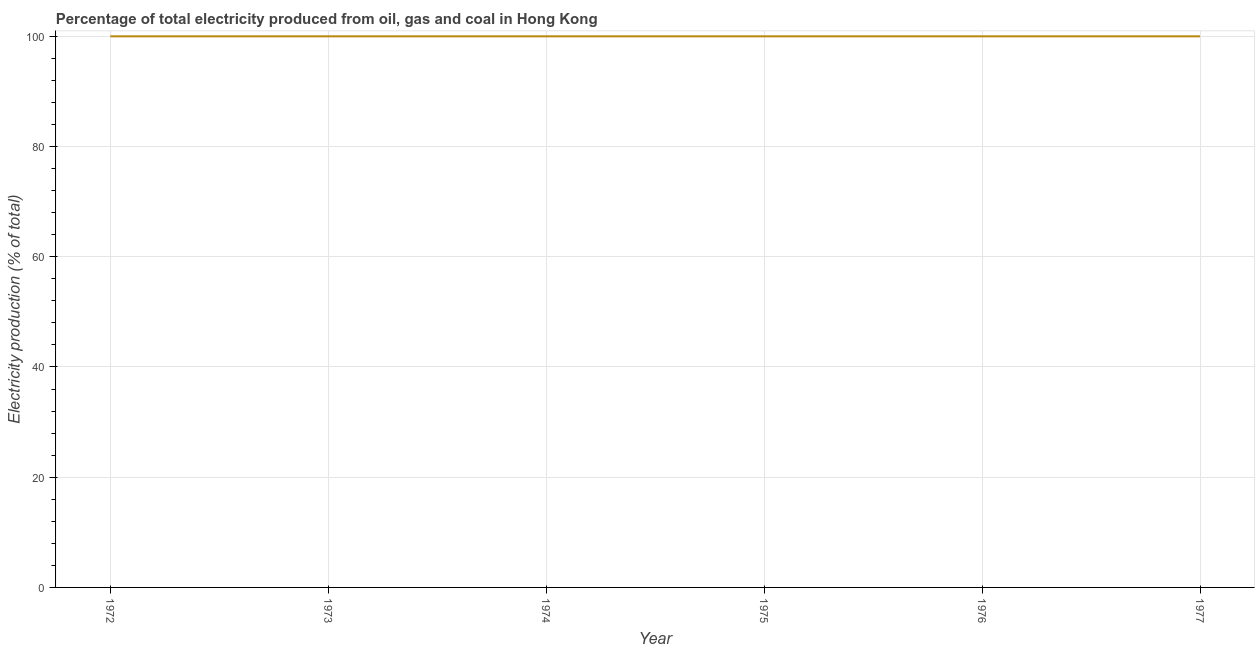What is the electricity production in 1975?
Your answer should be very brief. 100. Across all years, what is the maximum electricity production?
Give a very brief answer. 100. Across all years, what is the minimum electricity production?
Your response must be concise. 100. What is the sum of the electricity production?
Provide a short and direct response. 600. What is the median electricity production?
Keep it short and to the point. 100. Do a majority of the years between 1977 and 1972 (inclusive) have electricity production greater than 24 %?
Ensure brevity in your answer.  Yes. What is the ratio of the electricity production in 1973 to that in 1974?
Give a very brief answer. 1. Is the electricity production in 1975 less than that in 1976?
Your answer should be very brief. No. Is the difference between the electricity production in 1972 and 1976 greater than the difference between any two years?
Give a very brief answer. Yes. What is the difference between the highest and the second highest electricity production?
Provide a short and direct response. 0. What is the difference between the highest and the lowest electricity production?
Provide a short and direct response. 0. How many lines are there?
Your answer should be very brief. 1. What is the difference between two consecutive major ticks on the Y-axis?
Your response must be concise. 20. Does the graph contain any zero values?
Keep it short and to the point. No. What is the title of the graph?
Ensure brevity in your answer.  Percentage of total electricity produced from oil, gas and coal in Hong Kong. What is the label or title of the Y-axis?
Make the answer very short. Electricity production (% of total). What is the Electricity production (% of total) of 1973?
Offer a very short reply. 100. What is the Electricity production (% of total) in 1974?
Provide a succinct answer. 100. What is the Electricity production (% of total) in 1975?
Offer a terse response. 100. What is the Electricity production (% of total) in 1976?
Provide a succinct answer. 100. What is the Electricity production (% of total) in 1977?
Your response must be concise. 100. What is the difference between the Electricity production (% of total) in 1972 and 1974?
Provide a succinct answer. 0. What is the difference between the Electricity production (% of total) in 1972 and 1975?
Your answer should be compact. 0. What is the difference between the Electricity production (% of total) in 1972 and 1976?
Your answer should be very brief. 0. What is the difference between the Electricity production (% of total) in 1973 and 1977?
Give a very brief answer. 0. What is the difference between the Electricity production (% of total) in 1975 and 1976?
Provide a short and direct response. 0. What is the difference between the Electricity production (% of total) in 1976 and 1977?
Your answer should be compact. 0. What is the ratio of the Electricity production (% of total) in 1972 to that in 1973?
Your answer should be very brief. 1. What is the ratio of the Electricity production (% of total) in 1972 to that in 1974?
Offer a very short reply. 1. What is the ratio of the Electricity production (% of total) in 1972 to that in 1976?
Provide a short and direct response. 1. What is the ratio of the Electricity production (% of total) in 1972 to that in 1977?
Keep it short and to the point. 1. What is the ratio of the Electricity production (% of total) in 1974 to that in 1975?
Give a very brief answer. 1. What is the ratio of the Electricity production (% of total) in 1974 to that in 1977?
Make the answer very short. 1. What is the ratio of the Electricity production (% of total) in 1975 to that in 1976?
Your response must be concise. 1. What is the ratio of the Electricity production (% of total) in 1976 to that in 1977?
Provide a succinct answer. 1. 